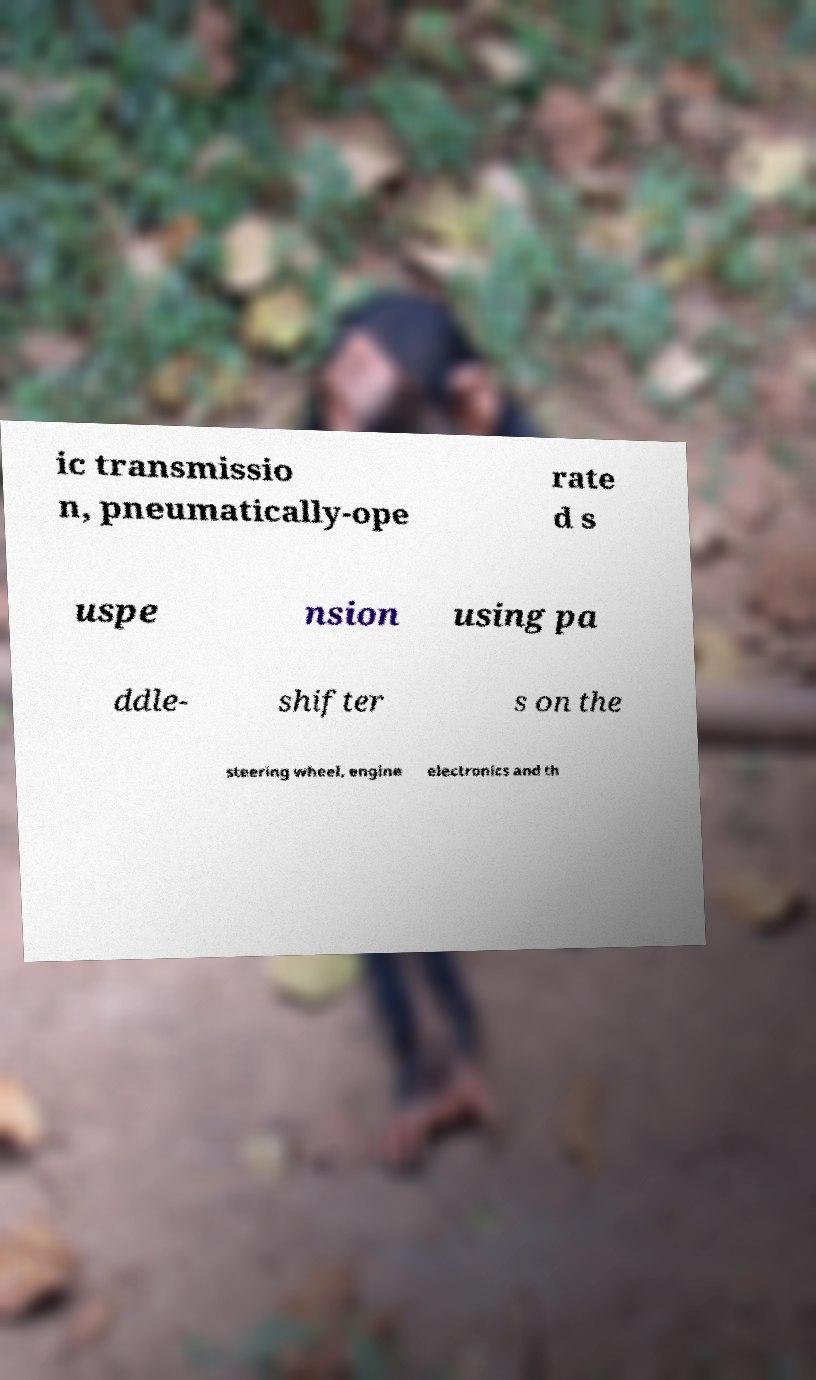Can you accurately transcribe the text from the provided image for me? ic transmissio n, pneumatically-ope rate d s uspe nsion using pa ddle- shifter s on the steering wheel, engine electronics and th 